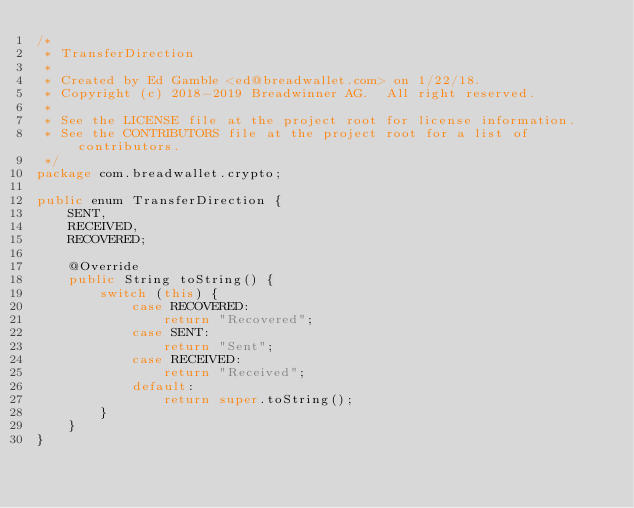<code> <loc_0><loc_0><loc_500><loc_500><_Java_>/*
 * TransferDirection
 *
 * Created by Ed Gamble <ed@breadwallet.com> on 1/22/18.
 * Copyright (c) 2018-2019 Breadwinner AG.  All right reserved.
 *
 * See the LICENSE file at the project root for license information.
 * See the CONTRIBUTORS file at the project root for a list of contributors.
 */
package com.breadwallet.crypto;

public enum TransferDirection {
    SENT,
    RECEIVED,
    RECOVERED;

    @Override
    public String toString() {
        switch (this) {
            case RECOVERED:
                return "Recovered";
            case SENT:
                return "Sent";
            case RECEIVED:
                return "Received";
            default:
                return super.toString();
        }
    }
}
</code> 